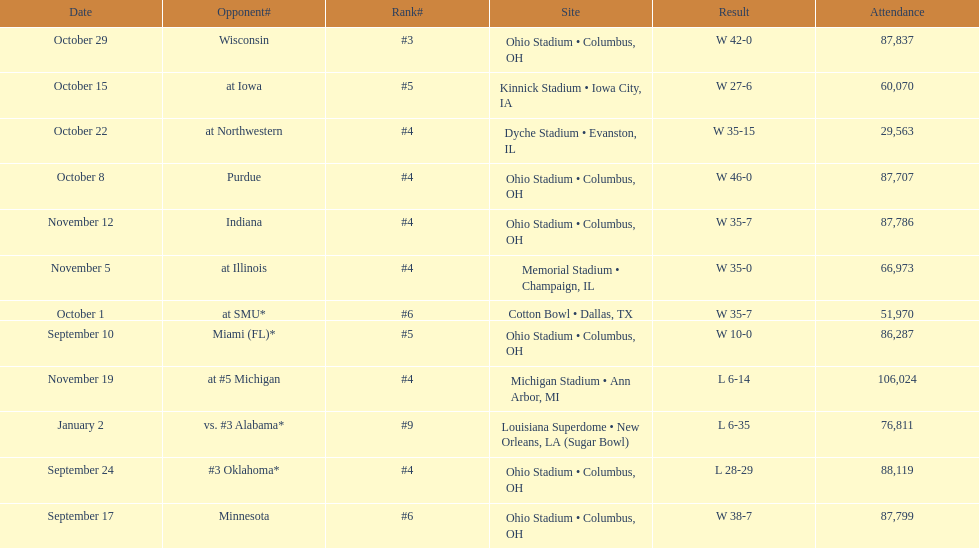On which date did the highest number of people attend? November 19. 